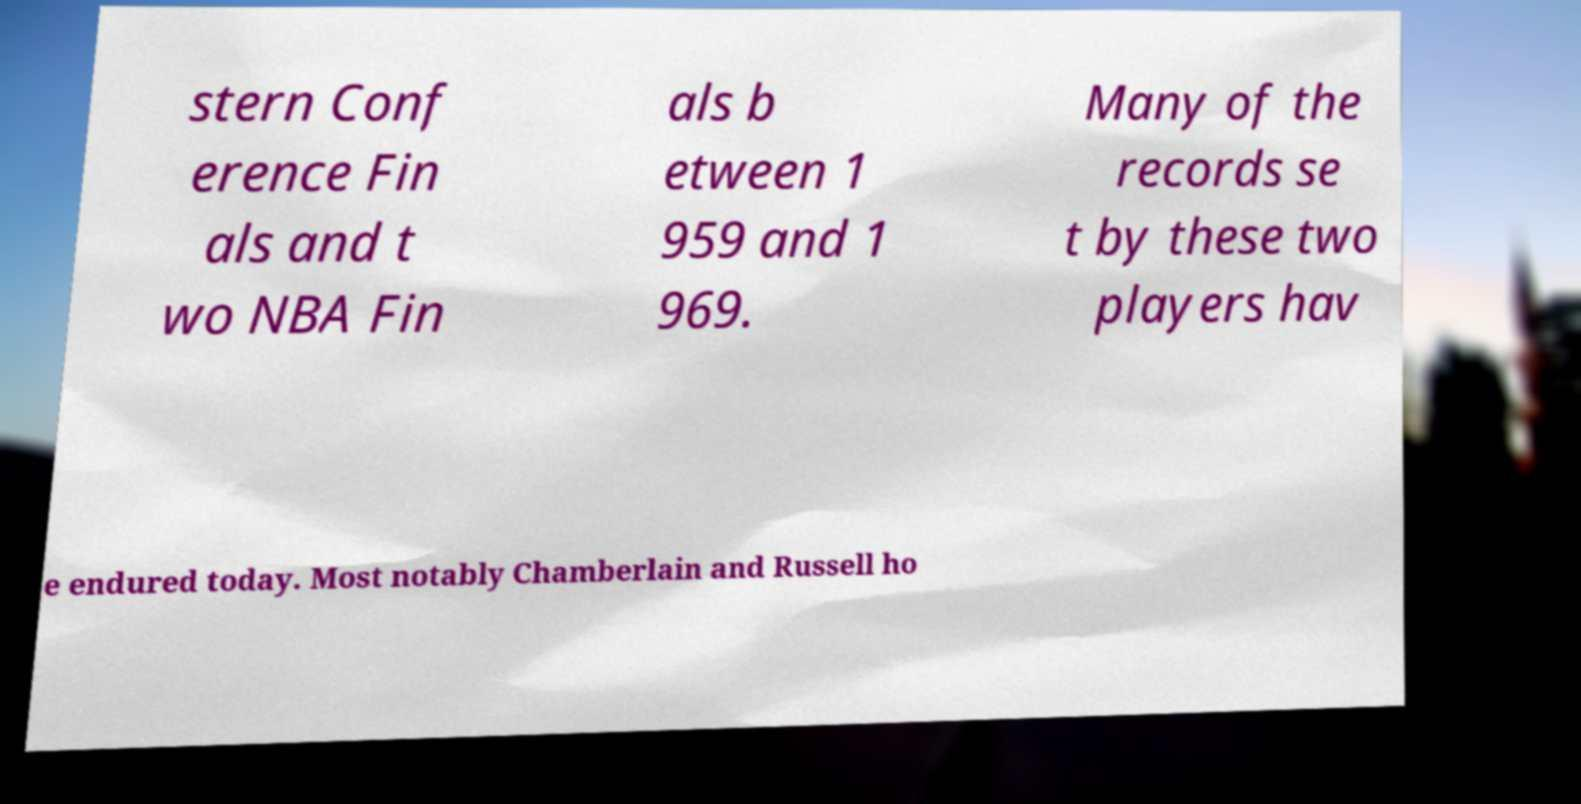Please read and relay the text visible in this image. What does it say? stern Conf erence Fin als and t wo NBA Fin als b etween 1 959 and 1 969. Many of the records se t by these two players hav e endured today. Most notably Chamberlain and Russell ho 